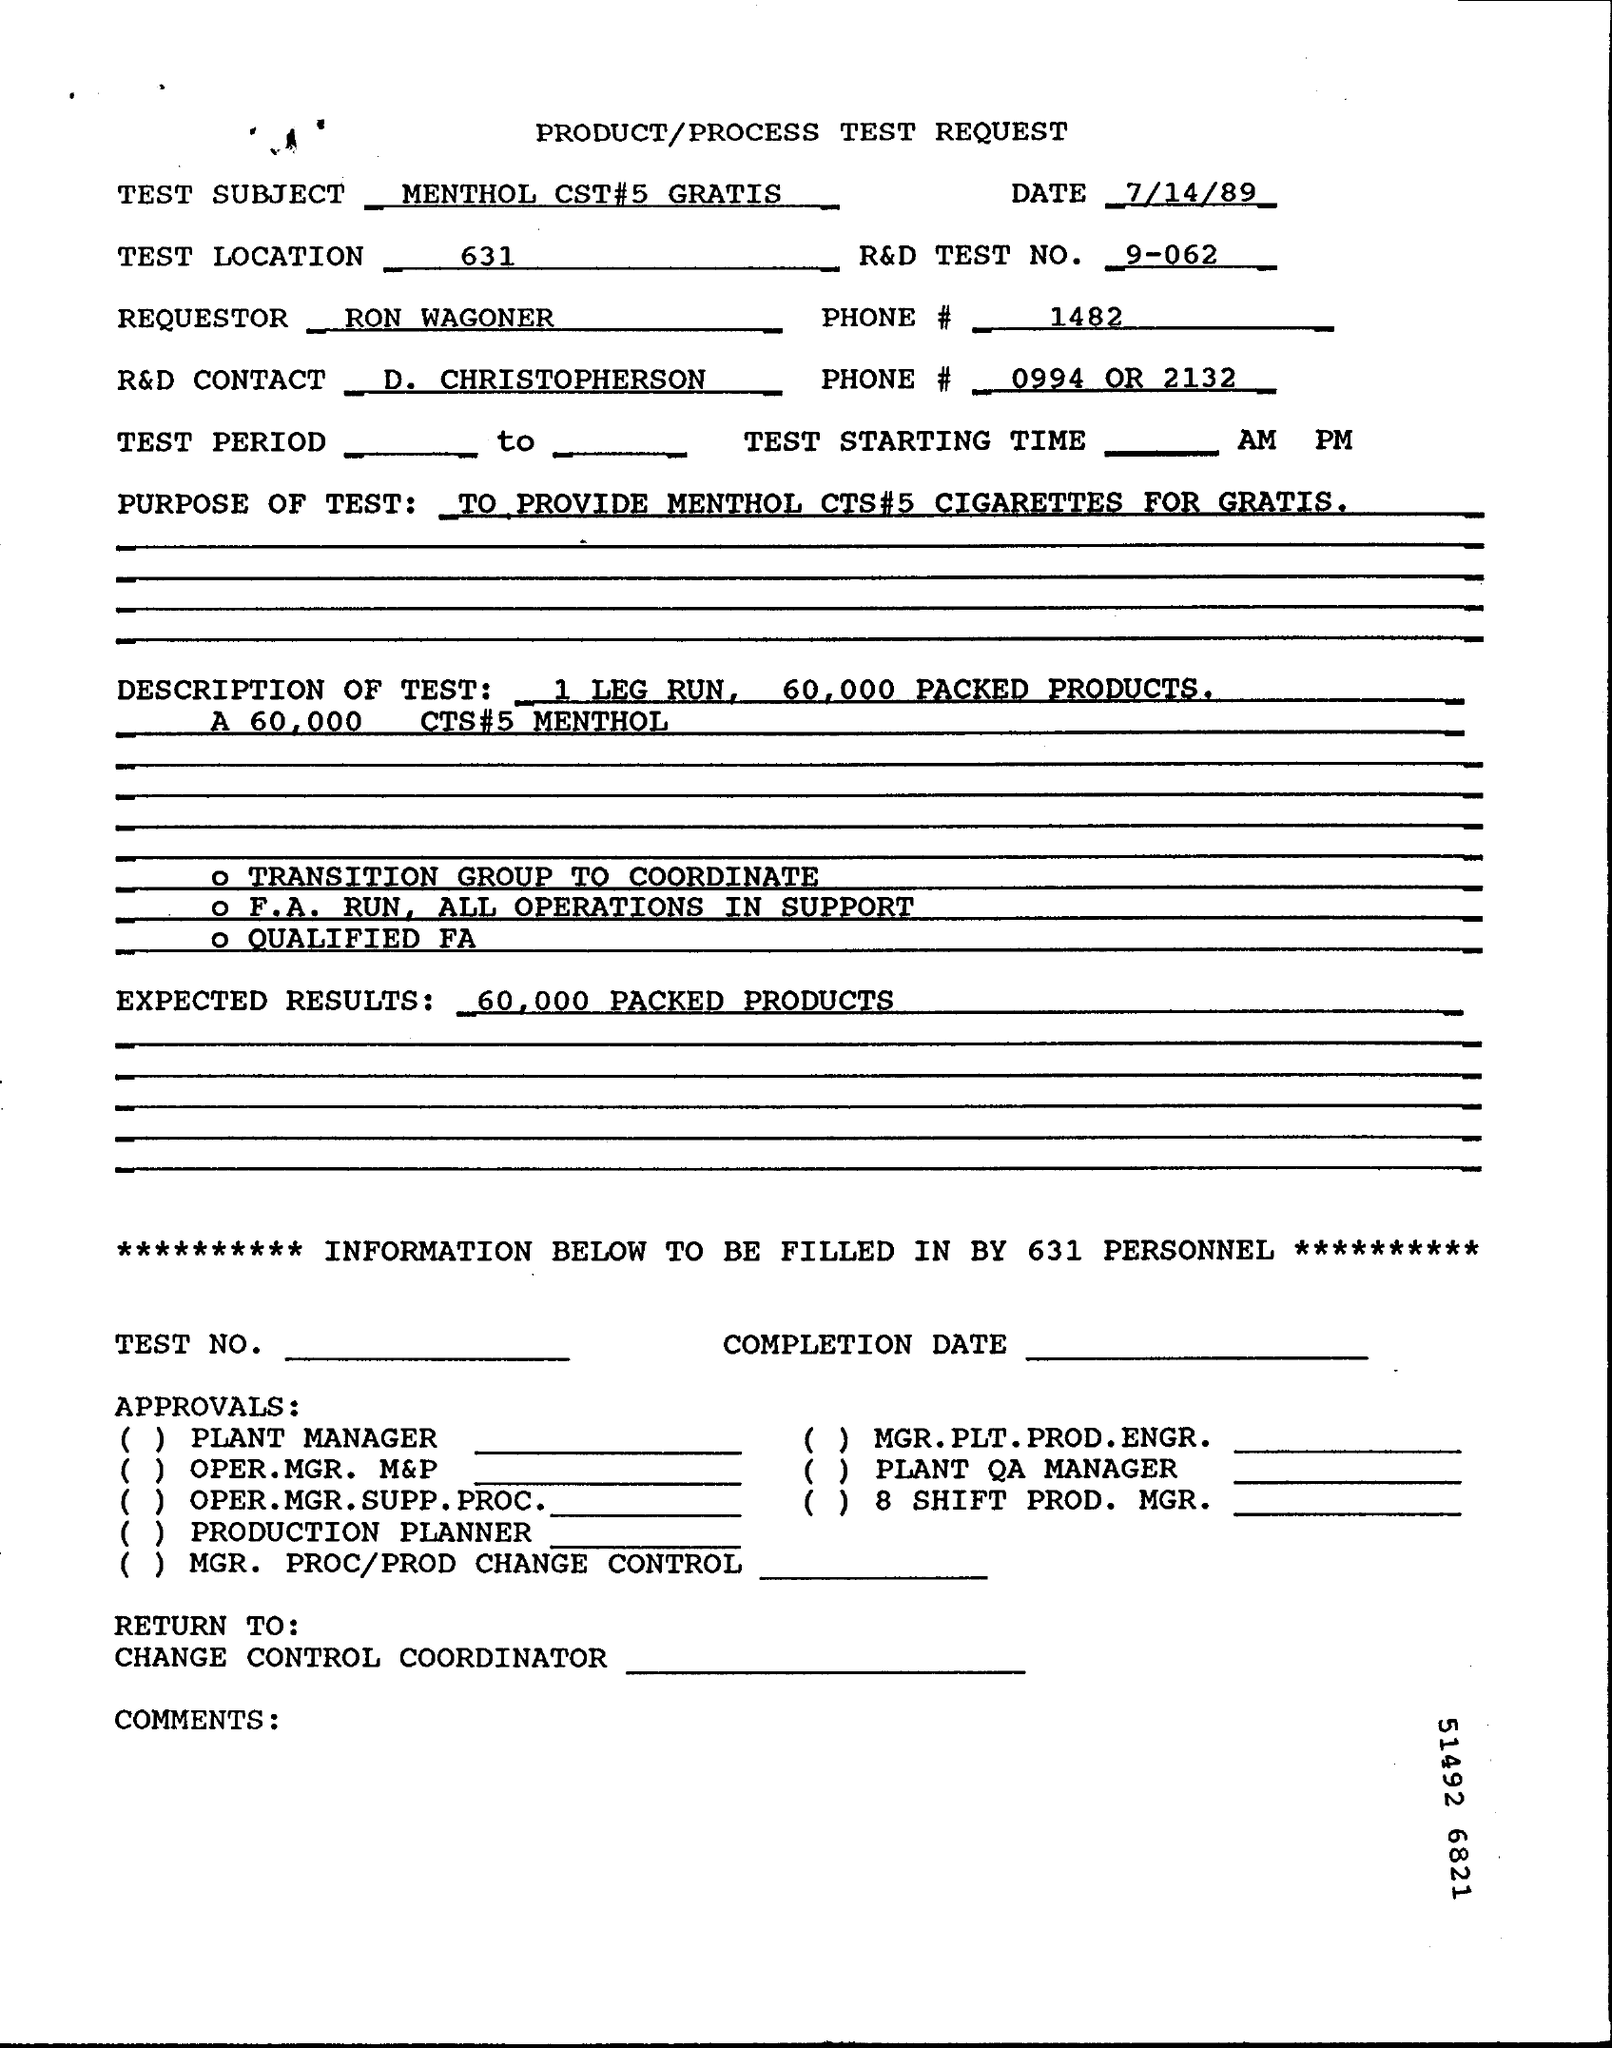Give some essential details in this illustration. What is the R&D Test No. 9-062? Our product has the potential to produce 60,000 packed products per hour, with a high level of efficiency and accuracy. The requestor is Ron Wagoner. The R&D CONTACT is D. CHRISTOPHERSON. The document is dated as of July 14, 1989. 